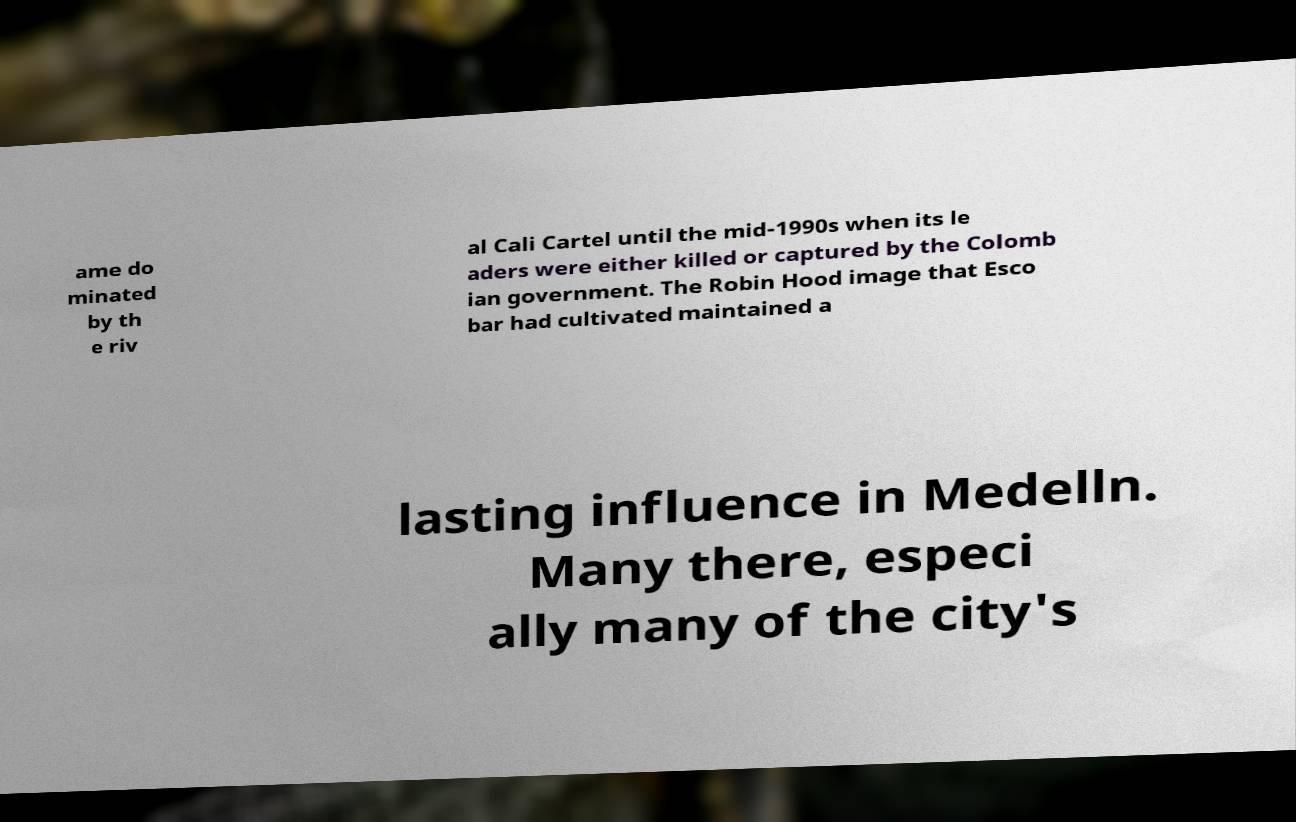There's text embedded in this image that I need extracted. Can you transcribe it verbatim? ame do minated by th e riv al Cali Cartel until the mid-1990s when its le aders were either killed or captured by the Colomb ian government. The Robin Hood image that Esco bar had cultivated maintained a lasting influence in Medelln. Many there, especi ally many of the city's 